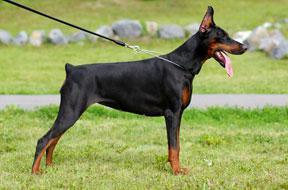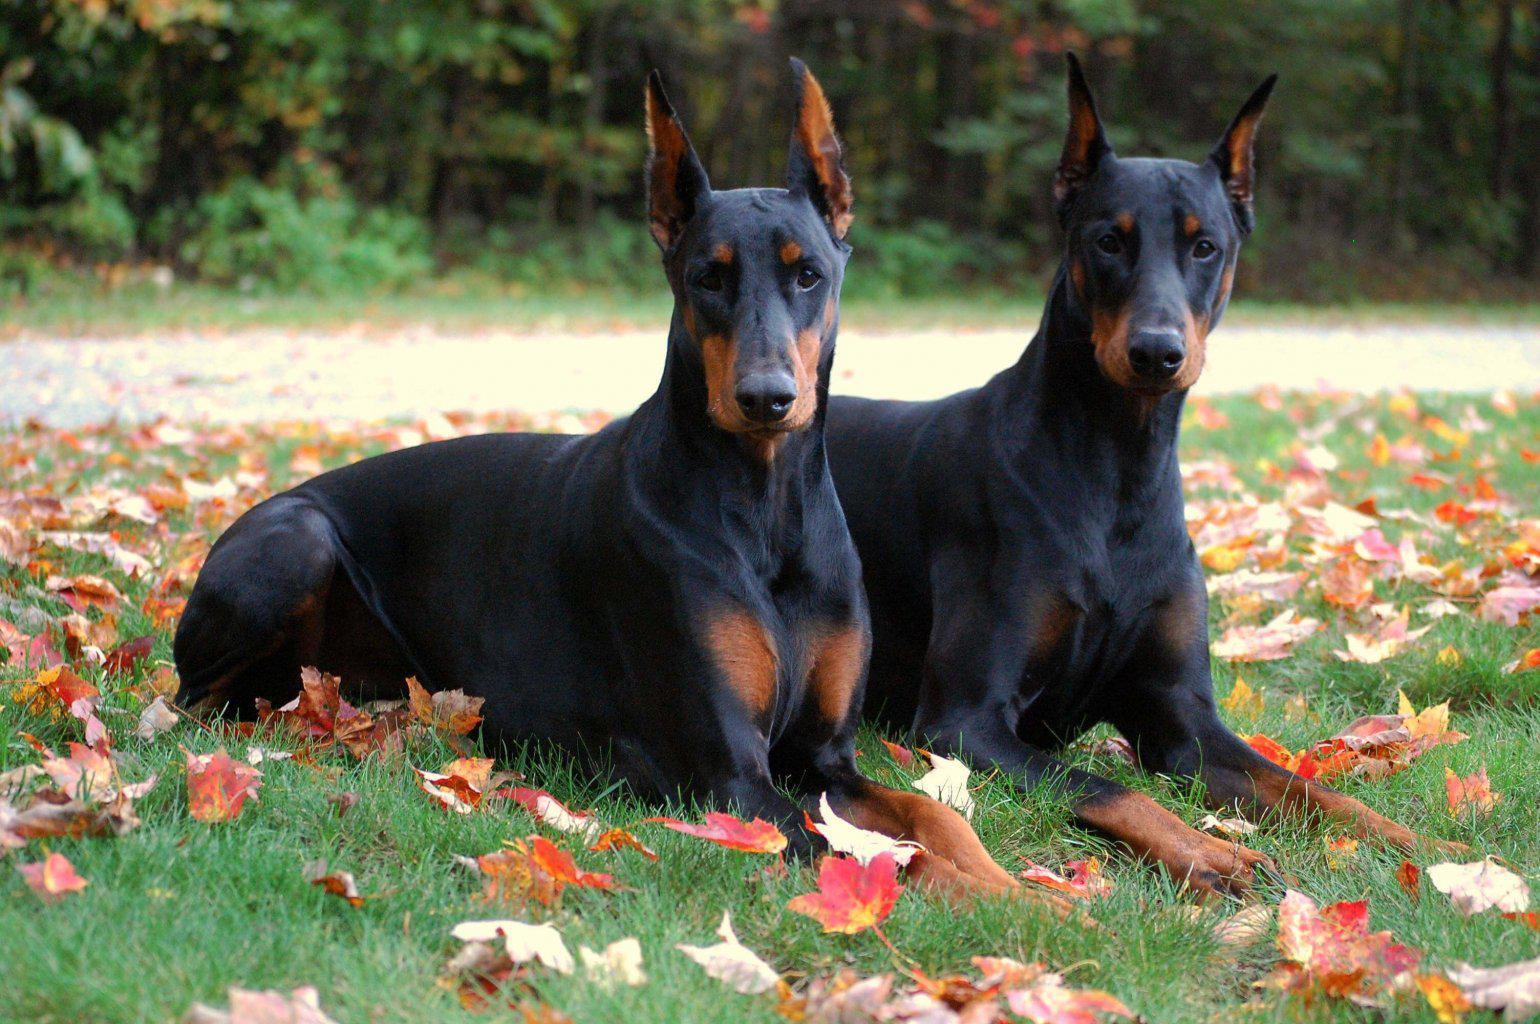The first image is the image on the left, the second image is the image on the right. Evaluate the accuracy of this statement regarding the images: "There are an equal number of dogs in each image.". Is it true? Answer yes or no. No. The first image is the image on the left, the second image is the image on the right. Evaluate the accuracy of this statement regarding the images: "Three dogs are present.". Is it true? Answer yes or no. Yes. 